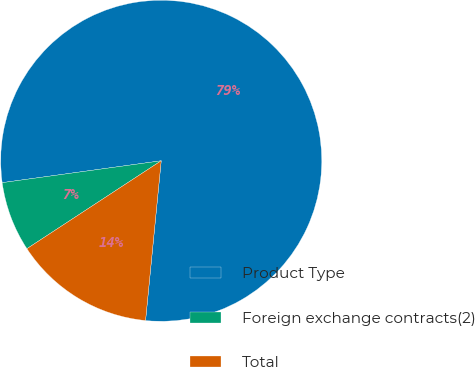Convert chart to OTSL. <chart><loc_0><loc_0><loc_500><loc_500><pie_chart><fcel>Product Type<fcel>Foreign exchange contracts(2)<fcel>Total<nl><fcel>78.74%<fcel>7.05%<fcel>14.22%<nl></chart> 